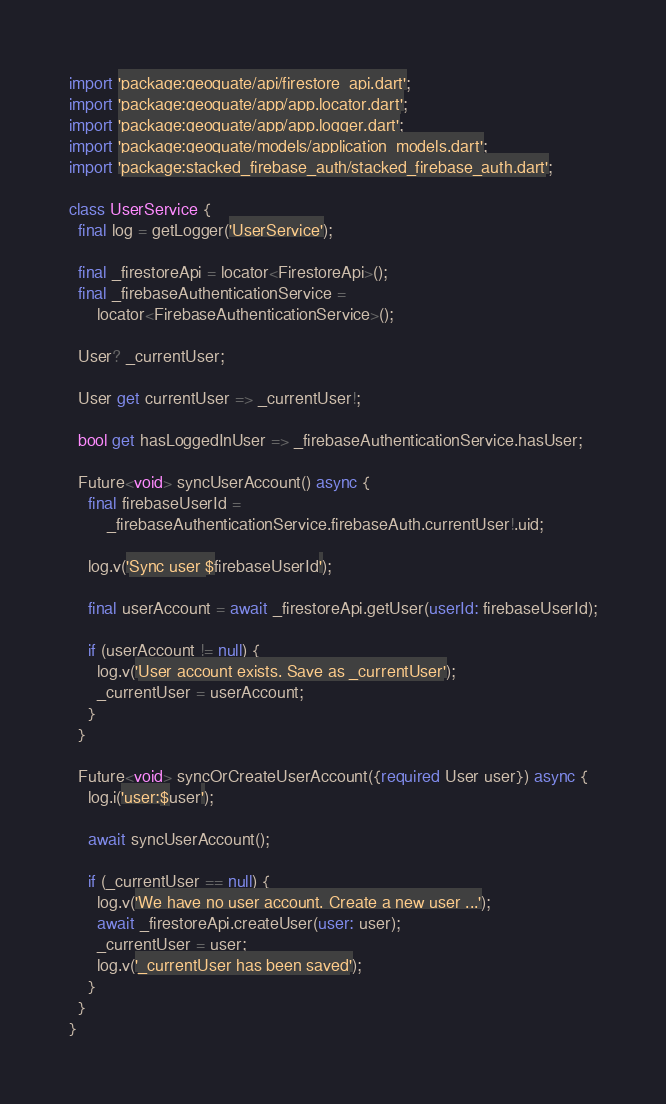<code> <loc_0><loc_0><loc_500><loc_500><_Dart_>import 'package:geoquate/api/firestore_api.dart';
import 'package:geoquate/app/app.locator.dart';
import 'package:geoquate/app/app.logger.dart';
import 'package:geoquate/models/application_models.dart';
import 'package:stacked_firebase_auth/stacked_firebase_auth.dart';

class UserService {
  final log = getLogger('UserService');

  final _firestoreApi = locator<FirestoreApi>();
  final _firebaseAuthenticationService =
      locator<FirebaseAuthenticationService>();

  User? _currentUser;

  User get currentUser => _currentUser!;

  bool get hasLoggedInUser => _firebaseAuthenticationService.hasUser;

  Future<void> syncUserAccount() async {
    final firebaseUserId =
        _firebaseAuthenticationService.firebaseAuth.currentUser!.uid;

    log.v('Sync user $firebaseUserId');

    final userAccount = await _firestoreApi.getUser(userId: firebaseUserId);

    if (userAccount != null) {
      log.v('User account exists. Save as _currentUser');
      _currentUser = userAccount;
    }
  }

  Future<void> syncOrCreateUserAccount({required User user}) async {
    log.i('user:$user');

    await syncUserAccount();

    if (_currentUser == null) {
      log.v('We have no user account. Create a new user ...');
      await _firestoreApi.createUser(user: user);
      _currentUser = user;
      log.v('_currentUser has been saved');
    }
  }
}
</code> 